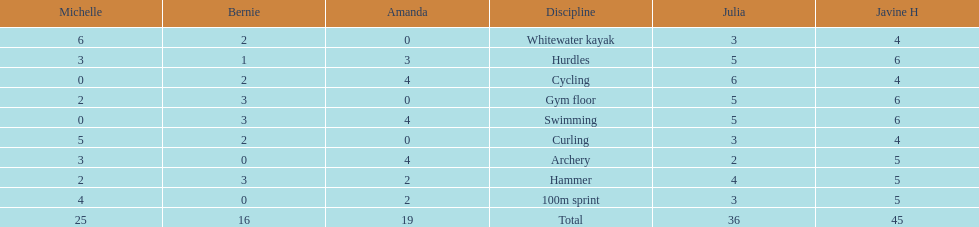Which of the girls had the least amount in archery? Bernie. 